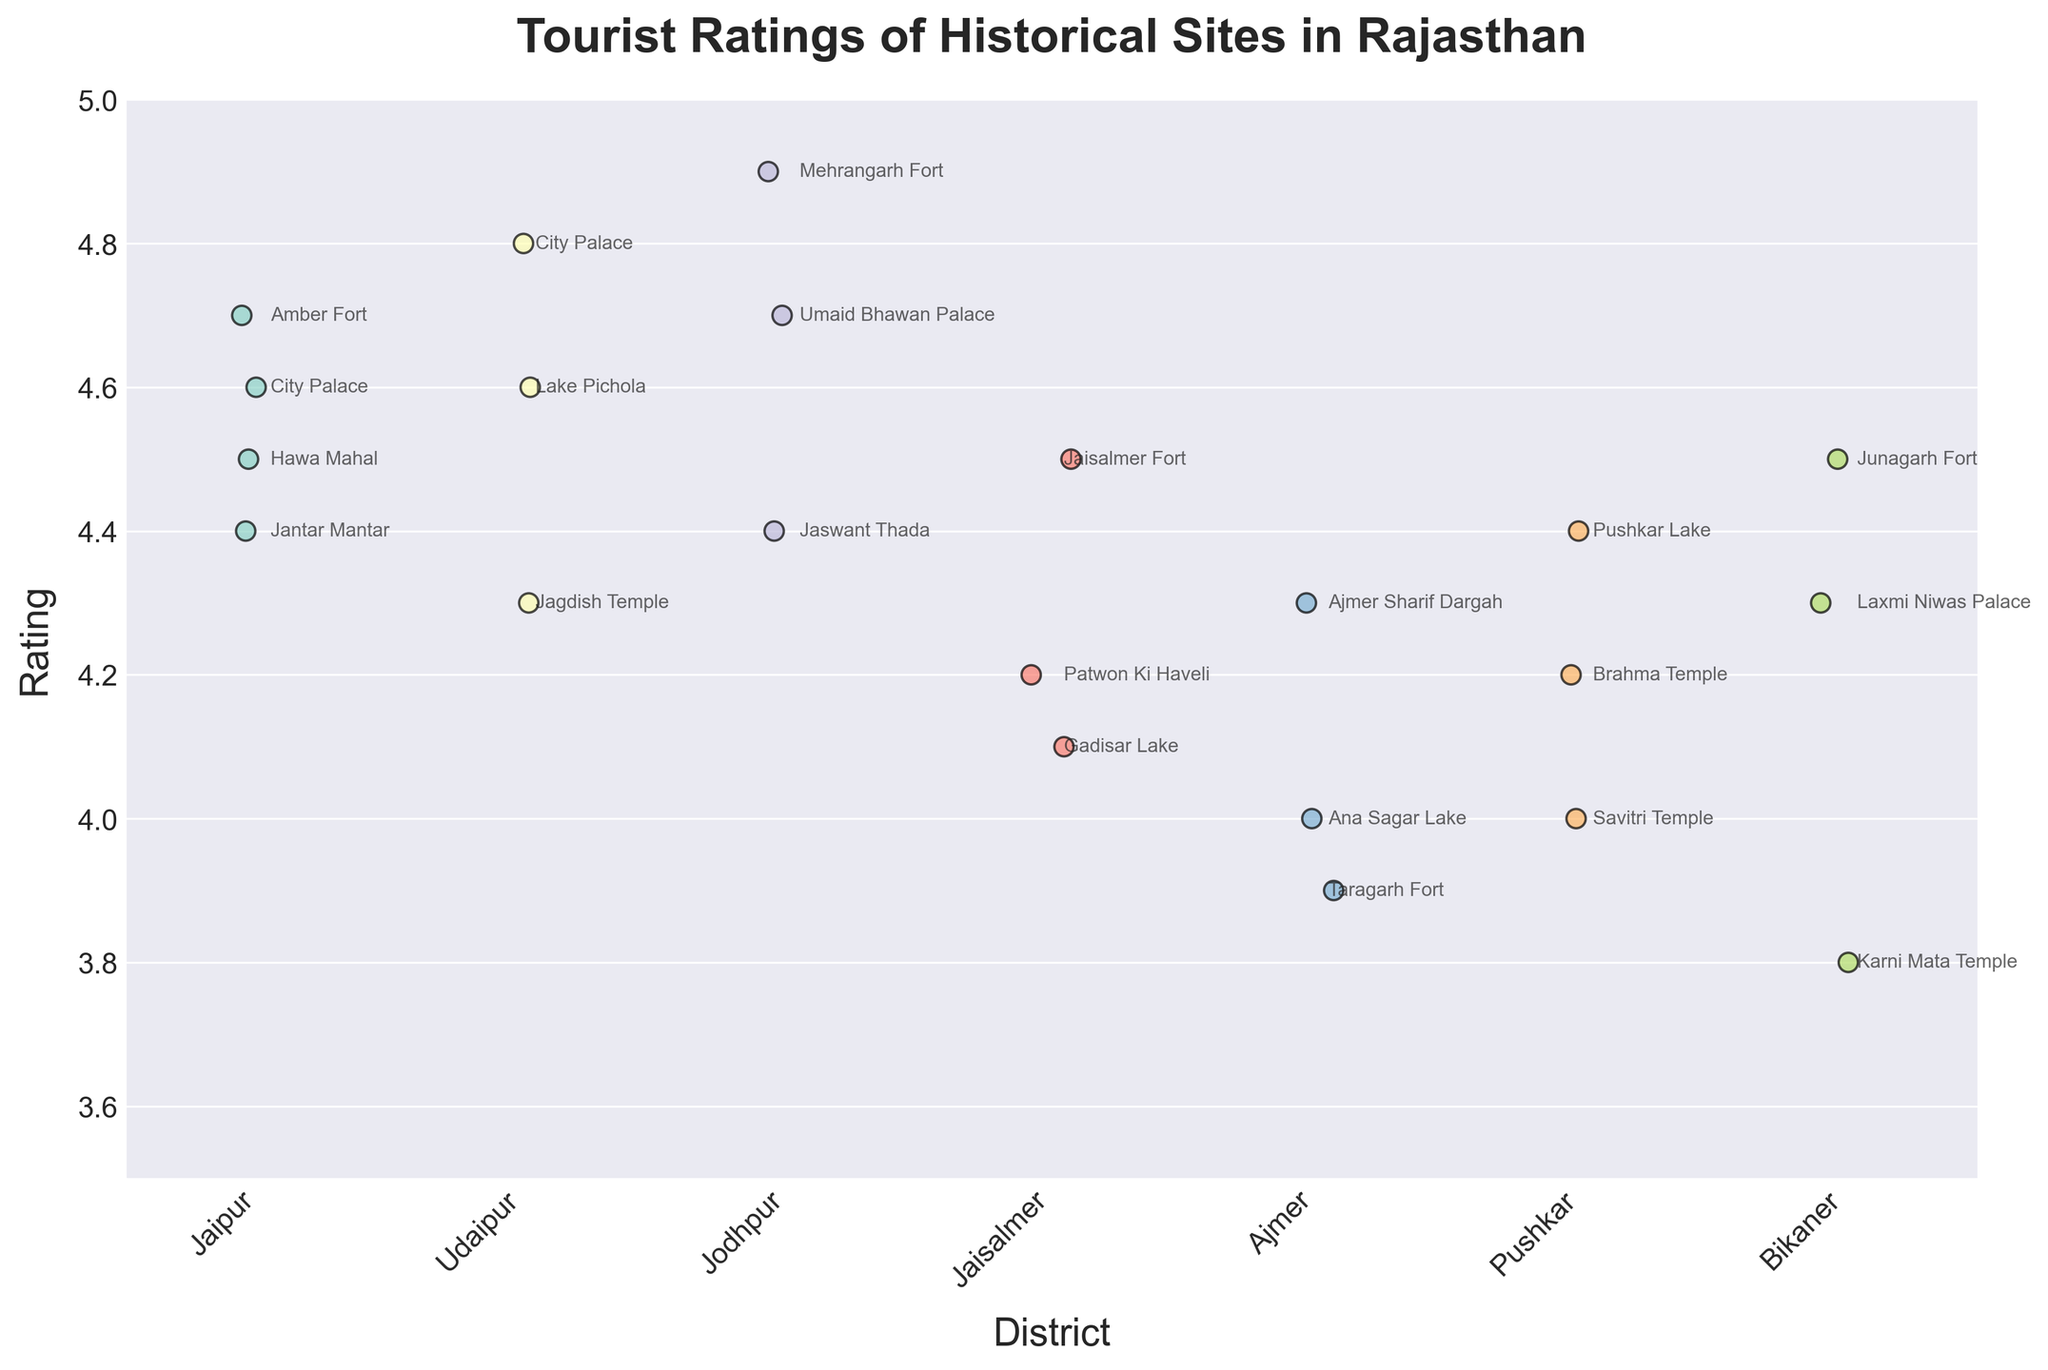What is the highest tourist rating among all historical sites? The highest tourist rating can be identified by looking for the highest point on the y-axis in the figure. The rating is 4.9 for Mehrangarh Fort in Jodhpur.
Answer: 4.9 Which district has the most consistently high ratings for its historical sites? By examining the spread and height of the data points for each district, Jaipur has many sites rated around 4.5-4.7, but Udaipur and Jodhpur have sites consistently rated around 4.4-4.9. Jodhpur is more consistent and higher rated overall.
Answer: Jodhpur How does the average rating of historical sites in Jaipur compare to those in Udaipur? Calculate the average rating for sites in Jaipur and Udaipur. Jaipur's ratings are 4.7, 4.5, 4.6, 4.4 averaging to (4.7 + 4.5 + 4.6 + 4.4)/4 = 4.55. Udaipur's ratings are 4.8, 4.6, 4.3 averaging to (4.8 + 4.6 + 4.3)/3 = 4.5667. Comparing these, Udaipur has a slightly higher average rating.
Answer: Udaipur Which historical site has the lowest tourist rating, and which district is it in? Identify the lowest point on the y-axis in the figure. Taragarh Fort in Ajmer has the lowest rating of 3.9.
Answer: Taragarh Fort in Ajmer Are there any districts where all historical sites have ratings above 4.0? Examine the y-axis ratings for each district. Jodhpur and Udaipur both have all historical sites rated above 4.0.
Answer: Jodhpur and Udaipur Compare the ratings of Hawa Mahal and Lake Pichola. Which one has a higher rating? Look at the specific points representing Hawa Mahal and Lake Pichola. Hawa Mahal has a rating of 4.5, and Lake Pichola has a rating of 4.6. Lake Pichola has a higher rating.
Answer: Lake Pichola Which historical site in Jaisalmer has the highest rating? Check the ratings for all historical sites in Jaisalmer. Jaisalmer Fort has the highest rating of 4.5.
Answer: Jaisalmer Fort How many historical sites in Pushkar have ratings equal to or above 4.0? Count the data points in the Pushkar district equal to or above 4.0 on the y-axis. Pushkar has three sites: Pushkar Lake (4.4), Brahma Temple (4.2), and Savitri Temple (4.0).
Answer: 3 What is the range of tourist ratings for historical sites in Ajmer? Determine the highest and lowest ratings in Ajmer. The highest is Ajmer Sharif Dargah (4.3) and the lowest is Taragarh Fort (3.9). The range is 4.3 - 3.9 = 0.4.
Answer: 0.4 